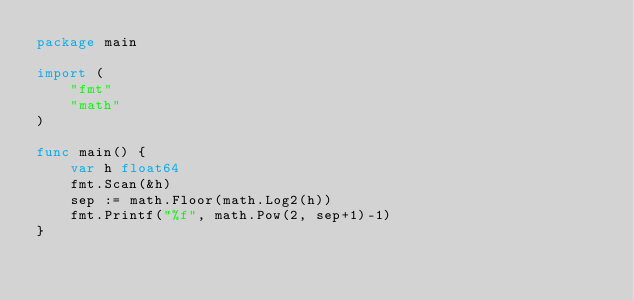Convert code to text. <code><loc_0><loc_0><loc_500><loc_500><_Go_>package main

import (
	"fmt"
	"math"
)

func main() {
	var h float64
	fmt.Scan(&h)
	sep := math.Floor(math.Log2(h))
	fmt.Printf("%f", math.Pow(2, sep+1)-1)
}
</code> 